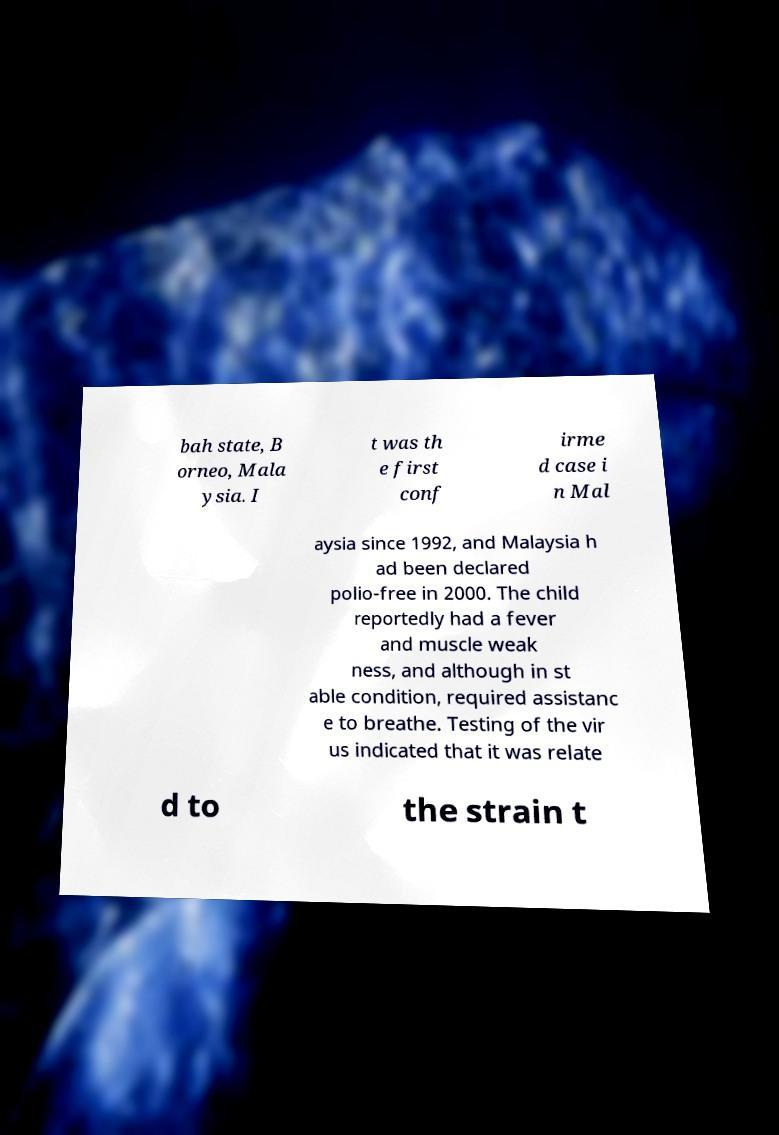Please identify and transcribe the text found in this image. bah state, B orneo, Mala ysia. I t was th e first conf irme d case i n Mal aysia since 1992, and Malaysia h ad been declared polio-free in 2000. The child reportedly had a fever and muscle weak ness, and although in st able condition, required assistanc e to breathe. Testing of the vir us indicated that it was relate d to the strain t 